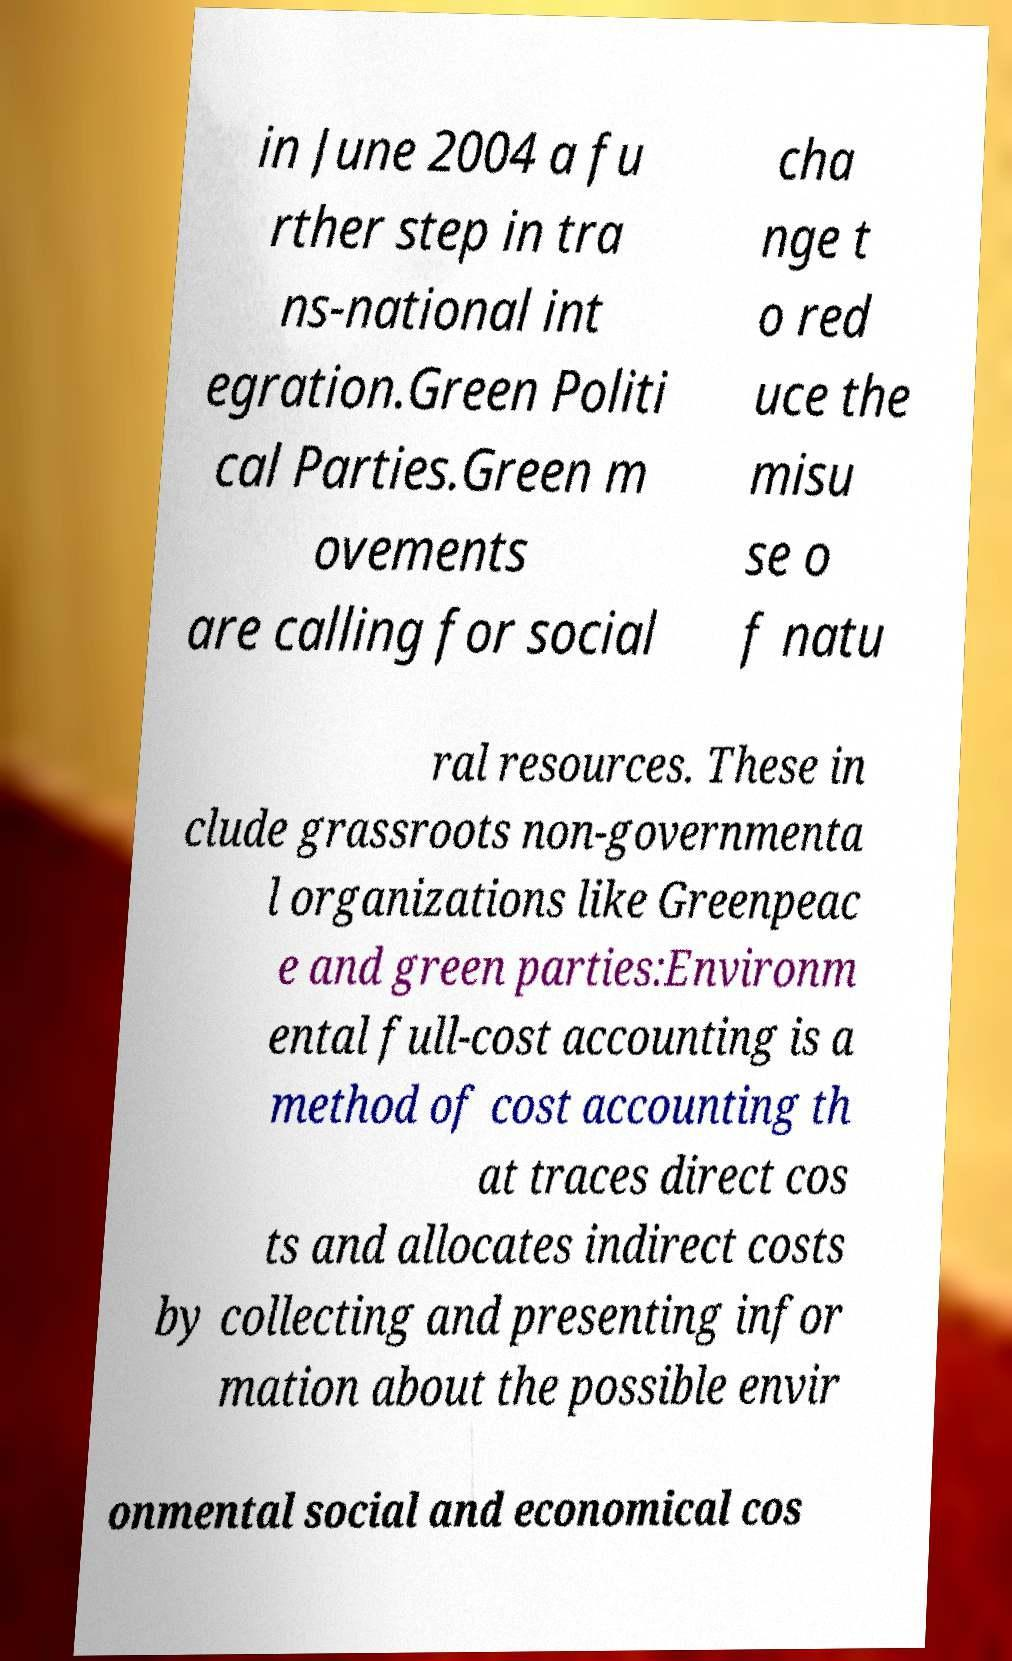Could you extract and type out the text from this image? in June 2004 a fu rther step in tra ns-national int egration.Green Politi cal Parties.Green m ovements are calling for social cha nge t o red uce the misu se o f natu ral resources. These in clude grassroots non-governmenta l organizations like Greenpeac e and green parties:Environm ental full-cost accounting is a method of cost accounting th at traces direct cos ts and allocates indirect costs by collecting and presenting infor mation about the possible envir onmental social and economical cos 